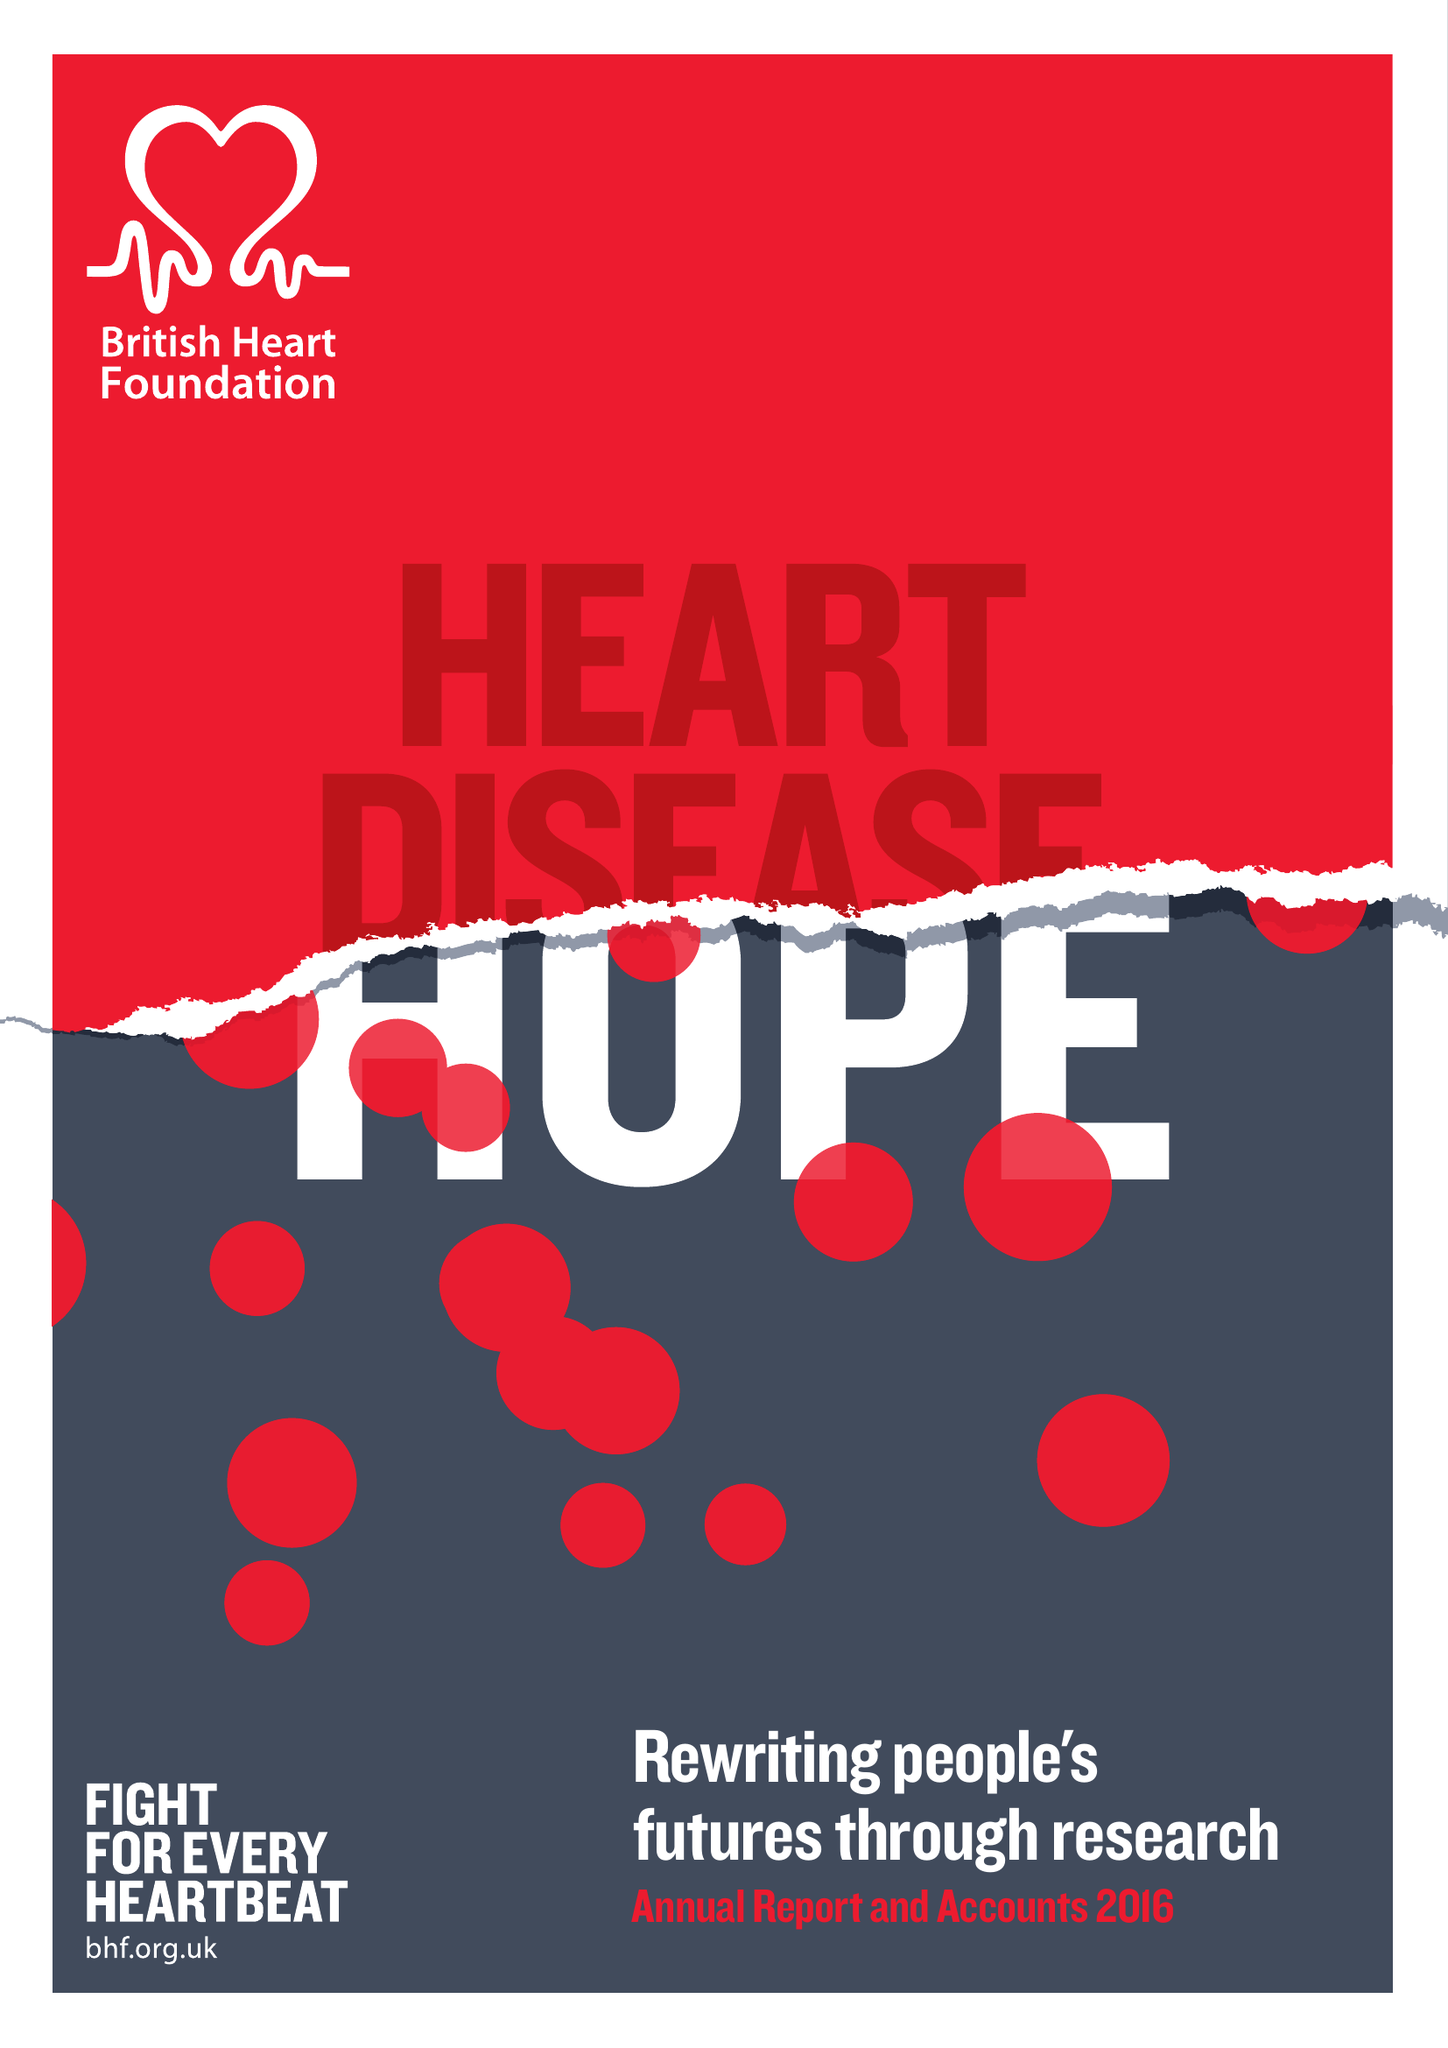What is the value for the spending_annually_in_british_pounds?
Answer the question using a single word or phrase. 316100000.00 